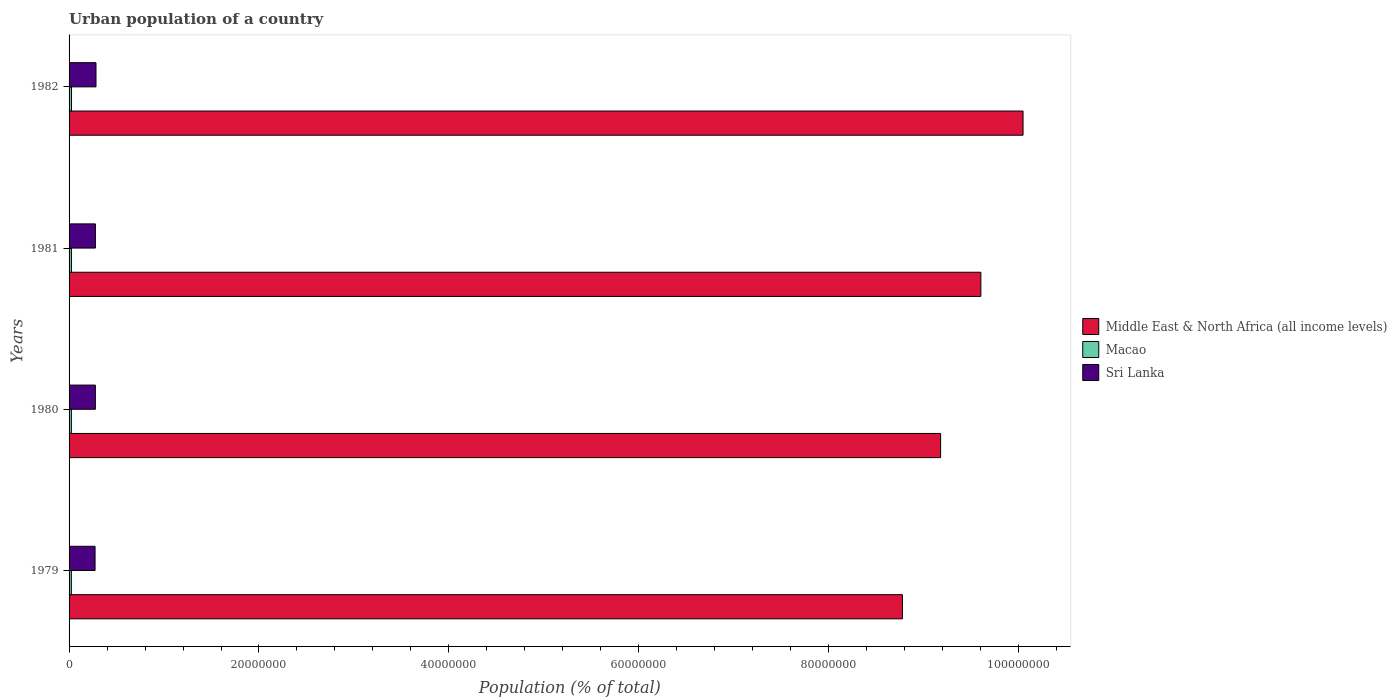How many groups of bars are there?
Offer a terse response. 4. What is the label of the 4th group of bars from the top?
Provide a short and direct response. 1979. What is the urban population in Macao in 1981?
Provide a succinct answer. 2.49e+05. Across all years, what is the maximum urban population in Middle East & North Africa (all income levels)?
Your answer should be very brief. 1.00e+08. Across all years, what is the minimum urban population in Middle East & North Africa (all income levels)?
Your answer should be compact. 8.78e+07. In which year was the urban population in Sri Lanka minimum?
Make the answer very short. 1979. What is the total urban population in Macao in the graph?
Provide a short and direct response. 9.89e+05. What is the difference between the urban population in Macao in 1981 and that in 1982?
Keep it short and to the point. -9157. What is the difference between the urban population in Middle East & North Africa (all income levels) in 1980 and the urban population in Sri Lanka in 1979?
Offer a terse response. 8.90e+07. What is the average urban population in Sri Lanka per year?
Your answer should be compact. 2.78e+06. In the year 1980, what is the difference between the urban population in Middle East & North Africa (all income levels) and urban population in Sri Lanka?
Give a very brief answer. 8.90e+07. In how many years, is the urban population in Middle East & North Africa (all income levels) greater than 100000000 %?
Your answer should be compact. 1. What is the ratio of the urban population in Sri Lanka in 1980 to that in 1982?
Keep it short and to the point. 0.98. What is the difference between the highest and the second highest urban population in Sri Lanka?
Your answer should be very brief. 6.34e+04. What is the difference between the highest and the lowest urban population in Middle East & North Africa (all income levels)?
Keep it short and to the point. 1.27e+07. In how many years, is the urban population in Middle East & North Africa (all income levels) greater than the average urban population in Middle East & North Africa (all income levels) taken over all years?
Provide a short and direct response. 2. What does the 2nd bar from the top in 1981 represents?
Your answer should be compact. Macao. What does the 1st bar from the bottom in 1981 represents?
Your answer should be very brief. Middle East & North Africa (all income levels). Is it the case that in every year, the sum of the urban population in Sri Lanka and urban population in Middle East & North Africa (all income levels) is greater than the urban population in Macao?
Offer a terse response. Yes. How many bars are there?
Your answer should be compact. 12. How many years are there in the graph?
Ensure brevity in your answer.  4. How many legend labels are there?
Offer a terse response. 3. What is the title of the graph?
Provide a short and direct response. Urban population of a country. Does "Lao PDR" appear as one of the legend labels in the graph?
Offer a terse response. No. What is the label or title of the X-axis?
Your answer should be compact. Population (% of total). What is the label or title of the Y-axis?
Make the answer very short. Years. What is the Population (% of total) in Middle East & North Africa (all income levels) in 1979?
Your answer should be very brief. 8.78e+07. What is the Population (% of total) in Macao in 1979?
Provide a short and direct response. 2.39e+05. What is the Population (% of total) in Sri Lanka in 1979?
Provide a succinct answer. 2.74e+06. What is the Population (% of total) of Middle East & North Africa (all income levels) in 1980?
Provide a short and direct response. 9.18e+07. What is the Population (% of total) in Macao in 1980?
Your response must be concise. 2.43e+05. What is the Population (% of total) in Sri Lanka in 1980?
Provide a short and direct response. 2.77e+06. What is the Population (% of total) of Middle East & North Africa (all income levels) in 1981?
Give a very brief answer. 9.60e+07. What is the Population (% of total) of Macao in 1981?
Keep it short and to the point. 2.49e+05. What is the Population (% of total) of Sri Lanka in 1981?
Keep it short and to the point. 2.77e+06. What is the Population (% of total) of Middle East & North Africa (all income levels) in 1982?
Give a very brief answer. 1.00e+08. What is the Population (% of total) in Macao in 1982?
Provide a succinct answer. 2.58e+05. What is the Population (% of total) of Sri Lanka in 1982?
Provide a succinct answer. 2.84e+06. Across all years, what is the maximum Population (% of total) of Middle East & North Africa (all income levels)?
Provide a succinct answer. 1.00e+08. Across all years, what is the maximum Population (% of total) of Macao?
Ensure brevity in your answer.  2.58e+05. Across all years, what is the maximum Population (% of total) in Sri Lanka?
Make the answer very short. 2.84e+06. Across all years, what is the minimum Population (% of total) in Middle East & North Africa (all income levels)?
Give a very brief answer. 8.78e+07. Across all years, what is the minimum Population (% of total) in Macao?
Your answer should be compact. 2.39e+05. Across all years, what is the minimum Population (% of total) of Sri Lanka?
Ensure brevity in your answer.  2.74e+06. What is the total Population (% of total) of Middle East & North Africa (all income levels) in the graph?
Your answer should be very brief. 3.76e+08. What is the total Population (% of total) in Macao in the graph?
Your response must be concise. 9.89e+05. What is the total Population (% of total) of Sri Lanka in the graph?
Your response must be concise. 1.11e+07. What is the difference between the Population (% of total) of Middle East & North Africa (all income levels) in 1979 and that in 1980?
Give a very brief answer. -4.02e+06. What is the difference between the Population (% of total) in Macao in 1979 and that in 1980?
Provide a short and direct response. -3381. What is the difference between the Population (% of total) in Sri Lanka in 1979 and that in 1980?
Your response must be concise. -3.15e+04. What is the difference between the Population (% of total) in Middle East & North Africa (all income levels) in 1979 and that in 1981?
Provide a succinct answer. -8.26e+06. What is the difference between the Population (% of total) in Macao in 1979 and that in 1981?
Keep it short and to the point. -9657. What is the difference between the Population (% of total) in Sri Lanka in 1979 and that in 1981?
Give a very brief answer. -3.50e+04. What is the difference between the Population (% of total) of Middle East & North Africa (all income levels) in 1979 and that in 1982?
Offer a very short reply. -1.27e+07. What is the difference between the Population (% of total) in Macao in 1979 and that in 1982?
Ensure brevity in your answer.  -1.88e+04. What is the difference between the Population (% of total) of Sri Lanka in 1979 and that in 1982?
Your answer should be compact. -9.84e+04. What is the difference between the Population (% of total) of Middle East & North Africa (all income levels) in 1980 and that in 1981?
Offer a very short reply. -4.24e+06. What is the difference between the Population (% of total) of Macao in 1980 and that in 1981?
Offer a very short reply. -6276. What is the difference between the Population (% of total) in Sri Lanka in 1980 and that in 1981?
Ensure brevity in your answer.  -3487. What is the difference between the Population (% of total) in Middle East & North Africa (all income levels) in 1980 and that in 1982?
Make the answer very short. -8.68e+06. What is the difference between the Population (% of total) of Macao in 1980 and that in 1982?
Your answer should be very brief. -1.54e+04. What is the difference between the Population (% of total) of Sri Lanka in 1980 and that in 1982?
Offer a very short reply. -6.68e+04. What is the difference between the Population (% of total) of Middle East & North Africa (all income levels) in 1981 and that in 1982?
Your answer should be very brief. -4.44e+06. What is the difference between the Population (% of total) in Macao in 1981 and that in 1982?
Offer a terse response. -9157. What is the difference between the Population (% of total) of Sri Lanka in 1981 and that in 1982?
Provide a succinct answer. -6.34e+04. What is the difference between the Population (% of total) in Middle East & North Africa (all income levels) in 1979 and the Population (% of total) in Macao in 1980?
Ensure brevity in your answer.  8.75e+07. What is the difference between the Population (% of total) of Middle East & North Africa (all income levels) in 1979 and the Population (% of total) of Sri Lanka in 1980?
Offer a terse response. 8.50e+07. What is the difference between the Population (% of total) in Macao in 1979 and the Population (% of total) in Sri Lanka in 1980?
Provide a succinct answer. -2.53e+06. What is the difference between the Population (% of total) of Middle East & North Africa (all income levels) in 1979 and the Population (% of total) of Macao in 1981?
Keep it short and to the point. 8.75e+07. What is the difference between the Population (% of total) of Middle East & North Africa (all income levels) in 1979 and the Population (% of total) of Sri Lanka in 1981?
Ensure brevity in your answer.  8.50e+07. What is the difference between the Population (% of total) in Macao in 1979 and the Population (% of total) in Sri Lanka in 1981?
Ensure brevity in your answer.  -2.53e+06. What is the difference between the Population (% of total) in Middle East & North Africa (all income levels) in 1979 and the Population (% of total) in Macao in 1982?
Make the answer very short. 8.75e+07. What is the difference between the Population (% of total) in Middle East & North Africa (all income levels) in 1979 and the Population (% of total) in Sri Lanka in 1982?
Provide a succinct answer. 8.49e+07. What is the difference between the Population (% of total) in Macao in 1979 and the Population (% of total) in Sri Lanka in 1982?
Give a very brief answer. -2.60e+06. What is the difference between the Population (% of total) of Middle East & North Africa (all income levels) in 1980 and the Population (% of total) of Macao in 1981?
Ensure brevity in your answer.  9.15e+07. What is the difference between the Population (% of total) in Middle East & North Africa (all income levels) in 1980 and the Population (% of total) in Sri Lanka in 1981?
Your response must be concise. 8.90e+07. What is the difference between the Population (% of total) in Macao in 1980 and the Population (% of total) in Sri Lanka in 1981?
Give a very brief answer. -2.53e+06. What is the difference between the Population (% of total) of Middle East & North Africa (all income levels) in 1980 and the Population (% of total) of Macao in 1982?
Your answer should be compact. 9.15e+07. What is the difference between the Population (% of total) of Middle East & North Africa (all income levels) in 1980 and the Population (% of total) of Sri Lanka in 1982?
Ensure brevity in your answer.  8.89e+07. What is the difference between the Population (% of total) in Macao in 1980 and the Population (% of total) in Sri Lanka in 1982?
Provide a short and direct response. -2.59e+06. What is the difference between the Population (% of total) in Middle East & North Africa (all income levels) in 1981 and the Population (% of total) in Macao in 1982?
Offer a terse response. 9.58e+07. What is the difference between the Population (% of total) in Middle East & North Africa (all income levels) in 1981 and the Population (% of total) in Sri Lanka in 1982?
Your response must be concise. 9.32e+07. What is the difference between the Population (% of total) of Macao in 1981 and the Population (% of total) of Sri Lanka in 1982?
Your response must be concise. -2.59e+06. What is the average Population (% of total) of Middle East & North Africa (all income levels) per year?
Your answer should be very brief. 9.40e+07. What is the average Population (% of total) in Macao per year?
Your response must be concise. 2.47e+05. What is the average Population (% of total) in Sri Lanka per year?
Give a very brief answer. 2.78e+06. In the year 1979, what is the difference between the Population (% of total) in Middle East & North Africa (all income levels) and Population (% of total) in Macao?
Your response must be concise. 8.75e+07. In the year 1979, what is the difference between the Population (% of total) of Middle East & North Africa (all income levels) and Population (% of total) of Sri Lanka?
Provide a short and direct response. 8.50e+07. In the year 1979, what is the difference between the Population (% of total) of Macao and Population (% of total) of Sri Lanka?
Ensure brevity in your answer.  -2.50e+06. In the year 1980, what is the difference between the Population (% of total) of Middle East & North Africa (all income levels) and Population (% of total) of Macao?
Keep it short and to the point. 9.15e+07. In the year 1980, what is the difference between the Population (% of total) in Middle East & North Africa (all income levels) and Population (% of total) in Sri Lanka?
Keep it short and to the point. 8.90e+07. In the year 1980, what is the difference between the Population (% of total) of Macao and Population (% of total) of Sri Lanka?
Your answer should be compact. -2.53e+06. In the year 1981, what is the difference between the Population (% of total) of Middle East & North Africa (all income levels) and Population (% of total) of Macao?
Your answer should be compact. 9.58e+07. In the year 1981, what is the difference between the Population (% of total) in Middle East & North Africa (all income levels) and Population (% of total) in Sri Lanka?
Your answer should be compact. 9.32e+07. In the year 1981, what is the difference between the Population (% of total) of Macao and Population (% of total) of Sri Lanka?
Provide a short and direct response. -2.52e+06. In the year 1982, what is the difference between the Population (% of total) of Middle East & North Africa (all income levels) and Population (% of total) of Macao?
Your answer should be very brief. 1.00e+08. In the year 1982, what is the difference between the Population (% of total) of Middle East & North Africa (all income levels) and Population (% of total) of Sri Lanka?
Provide a short and direct response. 9.76e+07. In the year 1982, what is the difference between the Population (% of total) in Macao and Population (% of total) in Sri Lanka?
Your answer should be very brief. -2.58e+06. What is the ratio of the Population (% of total) in Middle East & North Africa (all income levels) in 1979 to that in 1980?
Your response must be concise. 0.96. What is the ratio of the Population (% of total) of Macao in 1979 to that in 1980?
Give a very brief answer. 0.99. What is the ratio of the Population (% of total) in Middle East & North Africa (all income levels) in 1979 to that in 1981?
Ensure brevity in your answer.  0.91. What is the ratio of the Population (% of total) of Macao in 1979 to that in 1981?
Your answer should be compact. 0.96. What is the ratio of the Population (% of total) of Sri Lanka in 1979 to that in 1981?
Give a very brief answer. 0.99. What is the ratio of the Population (% of total) of Middle East & North Africa (all income levels) in 1979 to that in 1982?
Give a very brief answer. 0.87. What is the ratio of the Population (% of total) of Macao in 1979 to that in 1982?
Keep it short and to the point. 0.93. What is the ratio of the Population (% of total) in Sri Lanka in 1979 to that in 1982?
Ensure brevity in your answer.  0.97. What is the ratio of the Population (% of total) of Middle East & North Africa (all income levels) in 1980 to that in 1981?
Provide a short and direct response. 0.96. What is the ratio of the Population (% of total) of Macao in 1980 to that in 1981?
Give a very brief answer. 0.97. What is the ratio of the Population (% of total) in Sri Lanka in 1980 to that in 1981?
Ensure brevity in your answer.  1. What is the ratio of the Population (% of total) in Middle East & North Africa (all income levels) in 1980 to that in 1982?
Offer a terse response. 0.91. What is the ratio of the Population (% of total) of Macao in 1980 to that in 1982?
Ensure brevity in your answer.  0.94. What is the ratio of the Population (% of total) in Sri Lanka in 1980 to that in 1982?
Provide a succinct answer. 0.98. What is the ratio of the Population (% of total) in Middle East & North Africa (all income levels) in 1981 to that in 1982?
Give a very brief answer. 0.96. What is the ratio of the Population (% of total) in Macao in 1981 to that in 1982?
Your answer should be very brief. 0.96. What is the ratio of the Population (% of total) in Sri Lanka in 1981 to that in 1982?
Give a very brief answer. 0.98. What is the difference between the highest and the second highest Population (% of total) in Middle East & North Africa (all income levels)?
Offer a very short reply. 4.44e+06. What is the difference between the highest and the second highest Population (% of total) in Macao?
Offer a terse response. 9157. What is the difference between the highest and the second highest Population (% of total) of Sri Lanka?
Ensure brevity in your answer.  6.34e+04. What is the difference between the highest and the lowest Population (% of total) in Middle East & North Africa (all income levels)?
Your answer should be compact. 1.27e+07. What is the difference between the highest and the lowest Population (% of total) in Macao?
Your response must be concise. 1.88e+04. What is the difference between the highest and the lowest Population (% of total) in Sri Lanka?
Offer a terse response. 9.84e+04. 